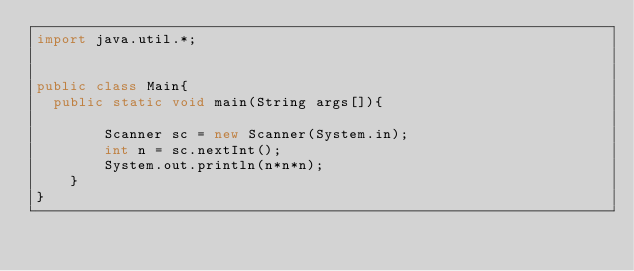<code> <loc_0><loc_0><loc_500><loc_500><_Java_>import java.util.*;


public class Main{
	public static void main(String args[]){
        
        Scanner sc = new Scanner(System.in);
        int n = sc.nextInt();
        System.out.println(n*n*n);
    }
}</code> 